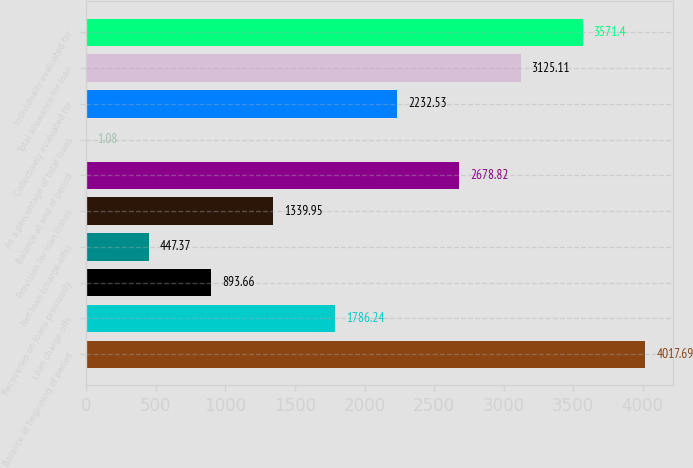Convert chart. <chart><loc_0><loc_0><loc_500><loc_500><bar_chart><fcel>Balance at beginning of period<fcel>Loan charge-offs<fcel>Recoveries on loans previously<fcel>Net loan (charge-offs)<fcel>Provision for loan losses<fcel>Balance at end of period<fcel>As a percentage of total loans<fcel>Collectively evaluated for<fcel>Total allowance for loan<fcel>Individually evaluated for<nl><fcel>4017.69<fcel>1786.24<fcel>893.66<fcel>447.37<fcel>1339.95<fcel>2678.82<fcel>1.08<fcel>2232.53<fcel>3125.11<fcel>3571.4<nl></chart> 